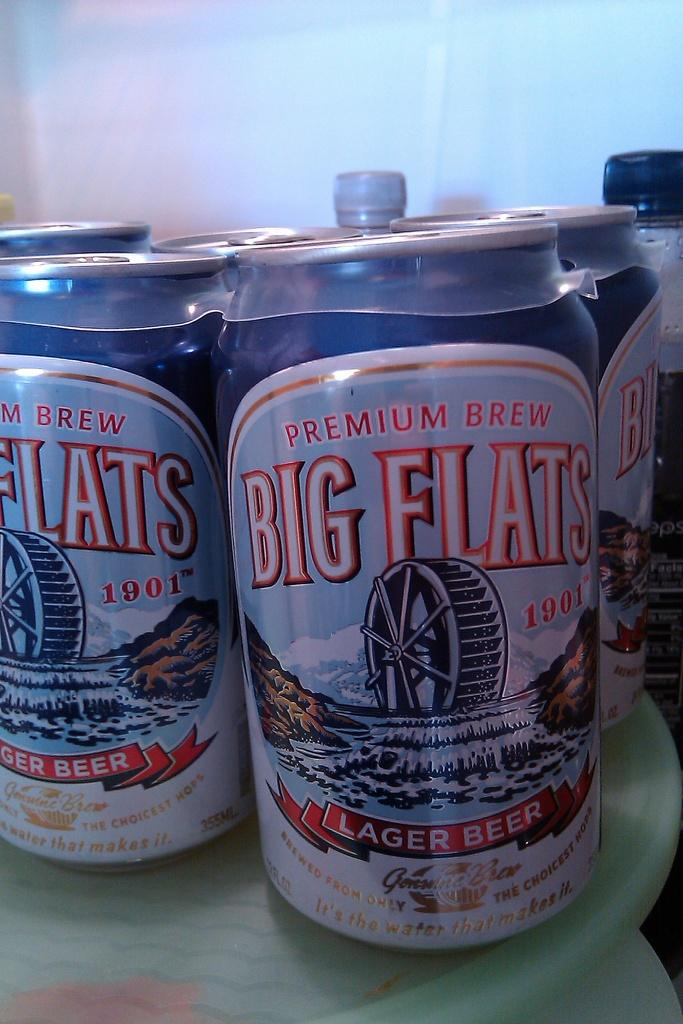<image>
Give a short and clear explanation of the subsequent image. A six pack of Premium Brew Big Flats Lager Beer cans. 